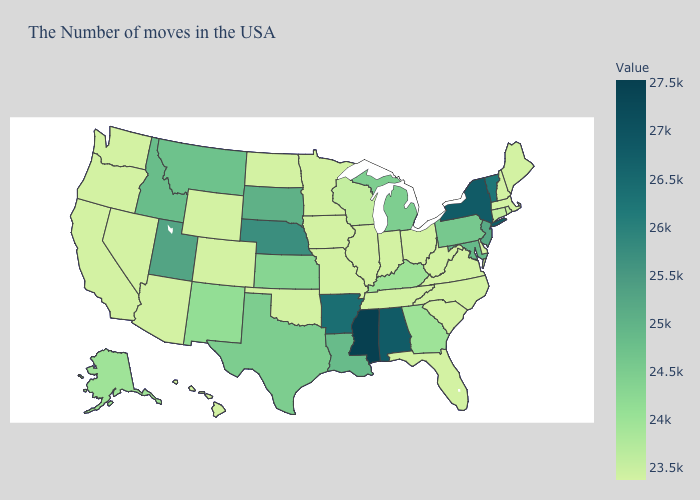Does Maryland have the highest value in the South?
Give a very brief answer. No. Among the states that border Delaware , which have the lowest value?
Concise answer only. Pennsylvania. Does Mississippi have the highest value in the USA?
Give a very brief answer. Yes. Does Massachusetts have the lowest value in the USA?
Write a very short answer. Yes. Does California have the lowest value in the USA?
Be succinct. Yes. Does Indiana have the lowest value in the USA?
Write a very short answer. Yes. Does Utah have the highest value in the West?
Answer briefly. Yes. Among the states that border North Dakota , does South Dakota have the lowest value?
Keep it brief. No. Is the legend a continuous bar?
Concise answer only. Yes. 